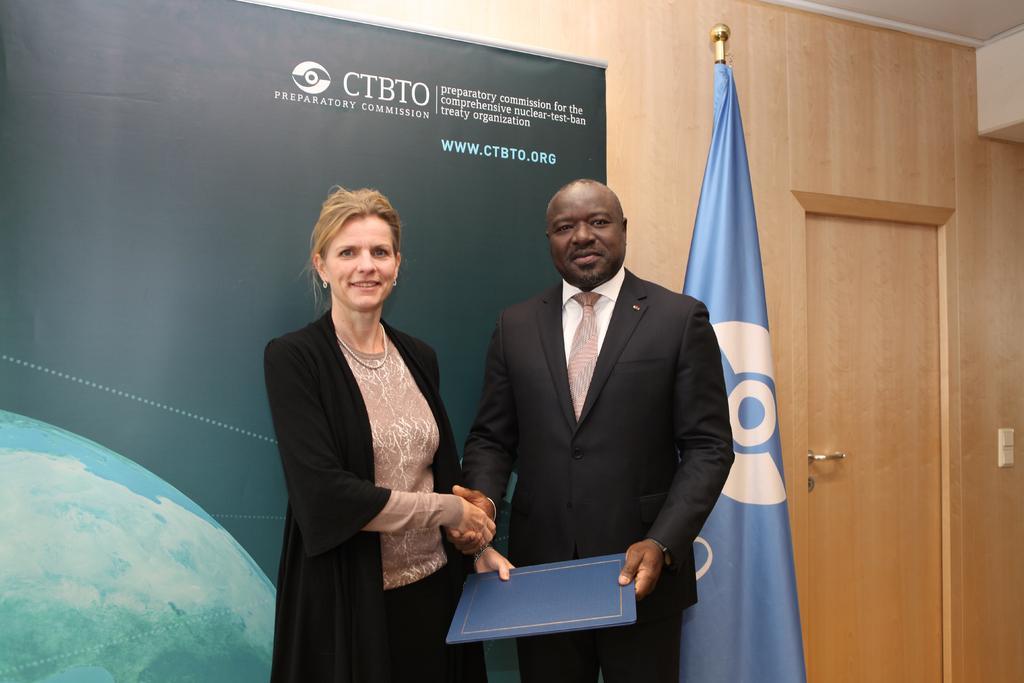Could you give a brief overview of what you see in this image? In this image I can see two people with black, brown and white color dresses. I can see these people are holding the blue color object. In the background I can see the banner, flag and the wooden wall. 